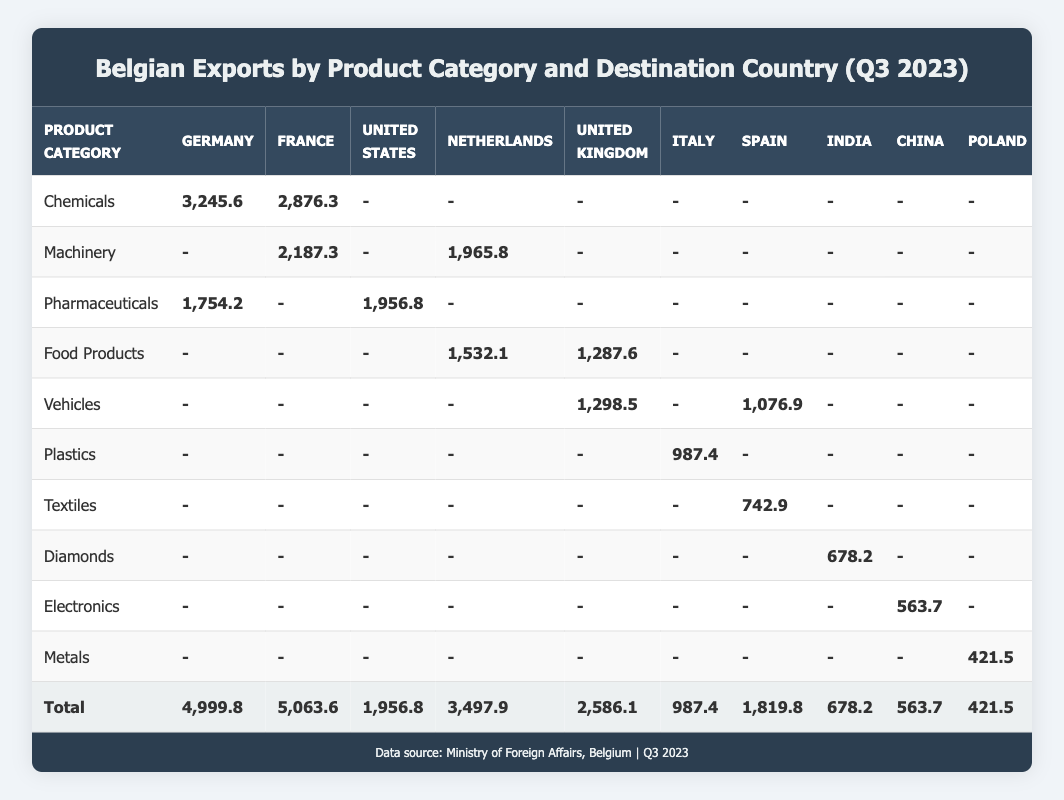What is the total export value of Belgian Chemicals to Germany? Looking at the row for Chemicals and the column for Germany, the export value listed is 3,245.6 million EUR.
Answer: 3,245.6 million EUR Which product category had the highest total export value? The total export value for each product category needs to be compared. For Chemicals, it's 6,121.9 million EUR; for Machinery, it's 4,153.1 million EUR; for Pharmaceuticals, it's 3,711.0 million EUR; Food Products is 2,819.7 million EUR; and Vehicles is 2,375.4 million EUR. Chemicals has the highest value at 6,121.9 million EUR.
Answer: Chemicals Is the export value of Textiles to Spain more than 700 million EUR? The export value for Textiles to Spain from the table is 742.9 million EUR, which is greater than 700 million EUR.
Answer: Yes What is the average export value of Belgian exports to the United Kingdom across all product categories? The total for the United Kingdom is summed up from various categories: 1,298.5 million EUR (Vehicles) + 1,287.6 million EUR (Food Products) = 2,586.1 million EUR. There are 2 product categories exporting to the UK, so the average is 2,586.1 million EUR / 2 = 1,293.05 million EUR.
Answer: 1,293.05 million EUR How much more did Belgium export in total to Germany compared to Poland? The total export value to Germany is 4,999.8 million EUR and to Poland is 421.5 million EUR. The difference is calculated as 4,999.8 million EUR - 421.5 million EUR = 4,578.3 million EUR.
Answer: 4,578.3 million EUR What percentage of the total exports does Pharmaceuticals account for? The total exports from the table is 22,574.8 million EUR. The value for Pharmaceuticals is 3,711.0 million EUR. Therefore, (3,711.0 / 22,574.8) * 100 = 16.43%.
Answer: 16.43% Did any product category export less than 1,000 million EUR to China? The only product category that exported to China is Electronics with an export value of 563.7 million EUR. Since this is less than 1,000 million EUR, the answer is yes.
Answer: Yes Which product category contributed the most to exports to the United States? Referring to the column for the United States, the highest export value in that column is for Pharmaceuticals at 1,956.8 million EUR.
Answer: Pharmaceuticals What was the total export value for Food Products? To find the total for Food Products, we add the exports to the Netherlands (1,532.1 million EUR) and the United Kingdom (1,287.6 million EUR). So, the total is 1,532.1 + 1,287.6 = 2,819.7 million EUR.
Answer: 2,819.7 million EUR 